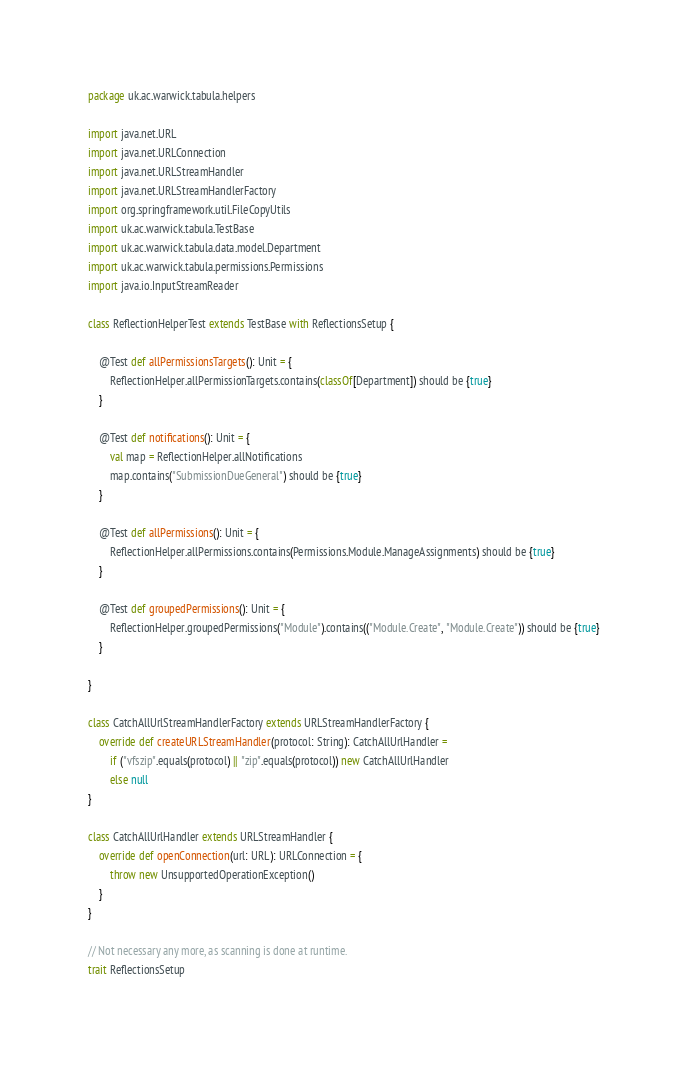Convert code to text. <code><loc_0><loc_0><loc_500><loc_500><_Scala_>package uk.ac.warwick.tabula.helpers

import java.net.URL
import java.net.URLConnection
import java.net.URLStreamHandler
import java.net.URLStreamHandlerFactory
import org.springframework.util.FileCopyUtils
import uk.ac.warwick.tabula.TestBase
import uk.ac.warwick.tabula.data.model.Department
import uk.ac.warwick.tabula.permissions.Permissions
import java.io.InputStreamReader

class ReflectionHelperTest extends TestBase with ReflectionsSetup {

	@Test def allPermissionsTargets(): Unit = {
		ReflectionHelper.allPermissionTargets.contains(classOf[Department]) should be {true}
	}

	@Test def notifications(): Unit = {
		val map = ReflectionHelper.allNotifications
		map.contains("SubmissionDueGeneral") should be {true}
	}

	@Test def allPermissions(): Unit = {
		ReflectionHelper.allPermissions.contains(Permissions.Module.ManageAssignments) should be {true}
	}

	@Test def groupedPermissions(): Unit = {
		ReflectionHelper.groupedPermissions("Module").contains(("Module.Create", "Module.Create")) should be {true}
	}

}

class CatchAllUrlStreamHandlerFactory extends URLStreamHandlerFactory {
	override def createURLStreamHandler(protocol: String): CatchAllUrlHandler =
		if ("vfszip".equals(protocol) || "zip".equals(protocol)) new CatchAllUrlHandler
		else null
}

class CatchAllUrlHandler extends URLStreamHandler {
	override def openConnection(url: URL): URLConnection = {
		throw new UnsupportedOperationException()
	}
}

// Not necessary any more, as scanning is done at runtime.
trait ReflectionsSetup</code> 